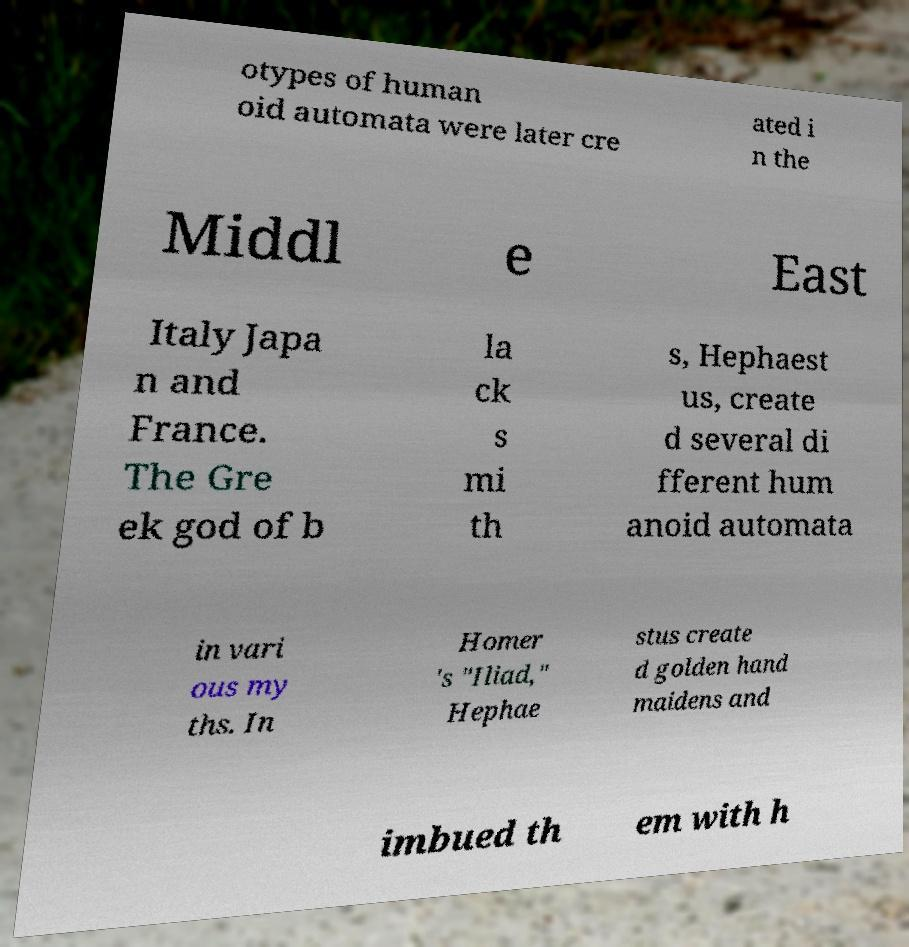I need the written content from this picture converted into text. Can you do that? otypes of human oid automata were later cre ated i n the Middl e East Italy Japa n and France. The Gre ek god of b la ck s mi th s, Hephaest us, create d several di fferent hum anoid automata in vari ous my ths. In Homer 's "Iliad," Hephae stus create d golden hand maidens and imbued th em with h 